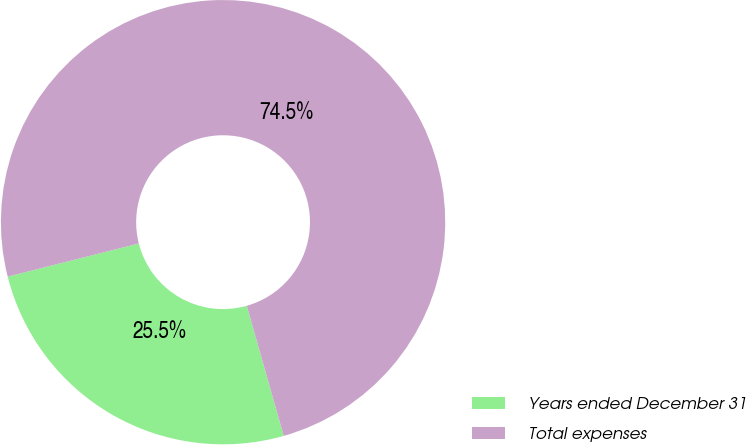<chart> <loc_0><loc_0><loc_500><loc_500><pie_chart><fcel>Years ended December 31<fcel>Total expenses<nl><fcel>25.46%<fcel>74.54%<nl></chart> 